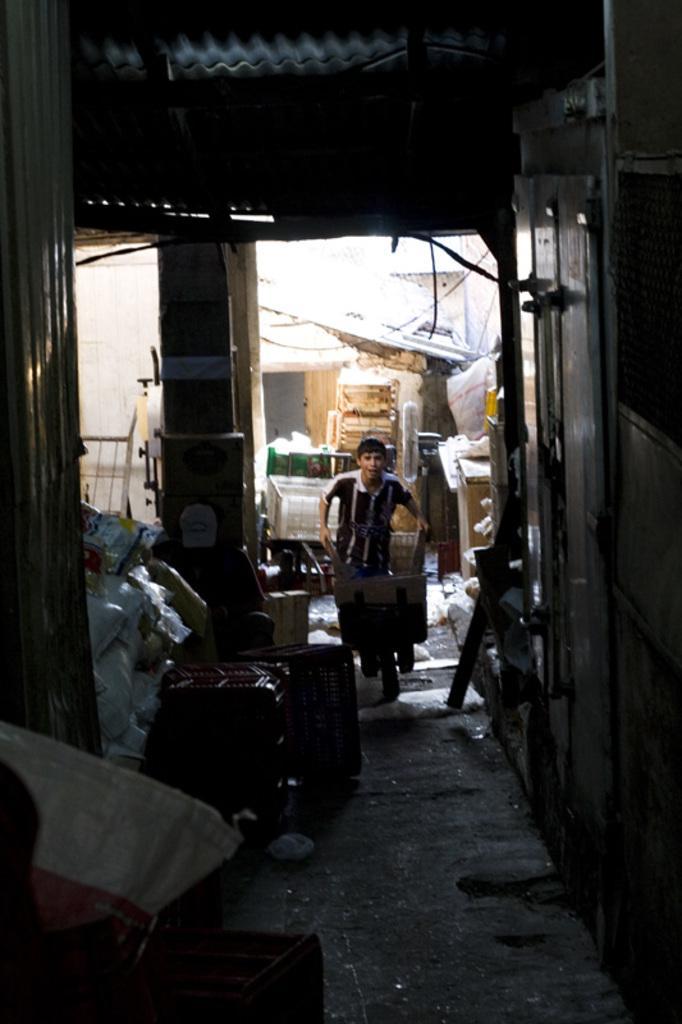Can you describe this image briefly? In this picture we can see a man, bags, pillars and in the background we can see some objects. 